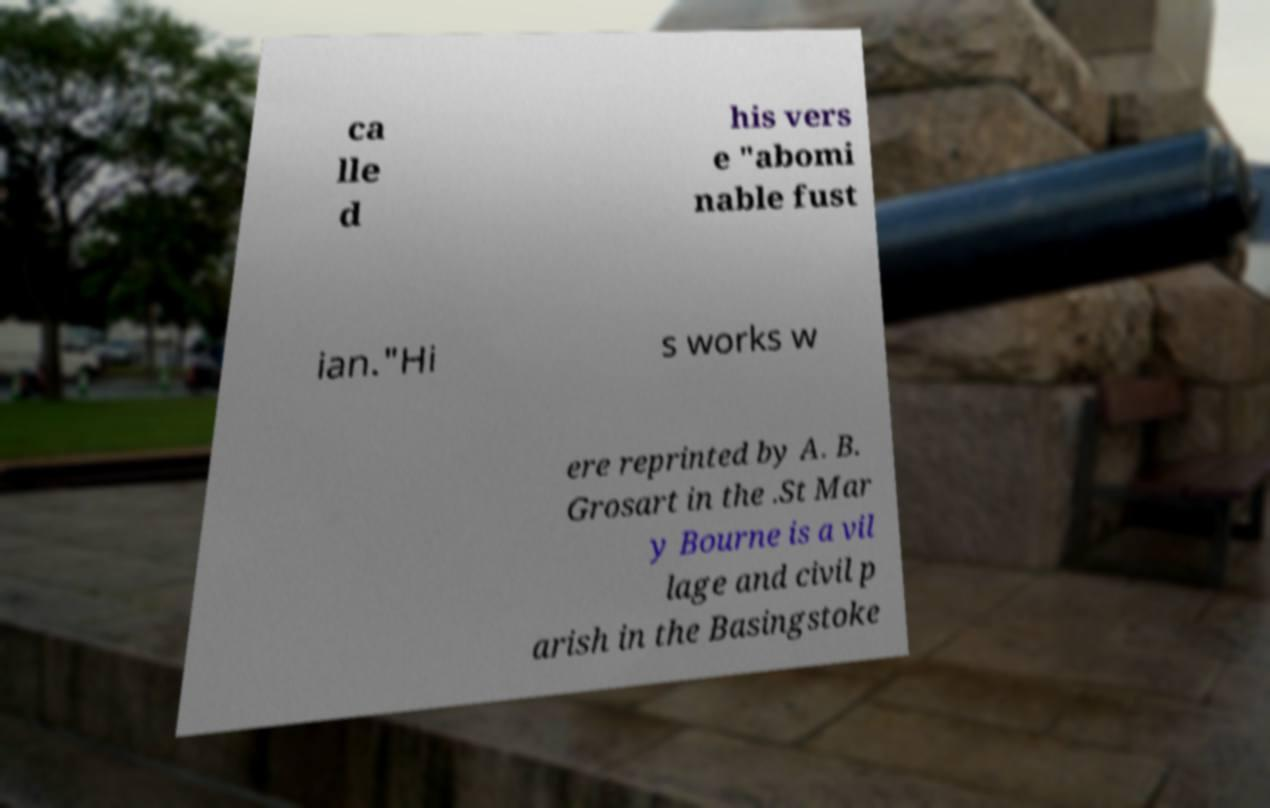For documentation purposes, I need the text within this image transcribed. Could you provide that? ca lle d his vers e "abomi nable fust ian."Hi s works w ere reprinted by A. B. Grosart in the .St Mar y Bourne is a vil lage and civil p arish in the Basingstoke 